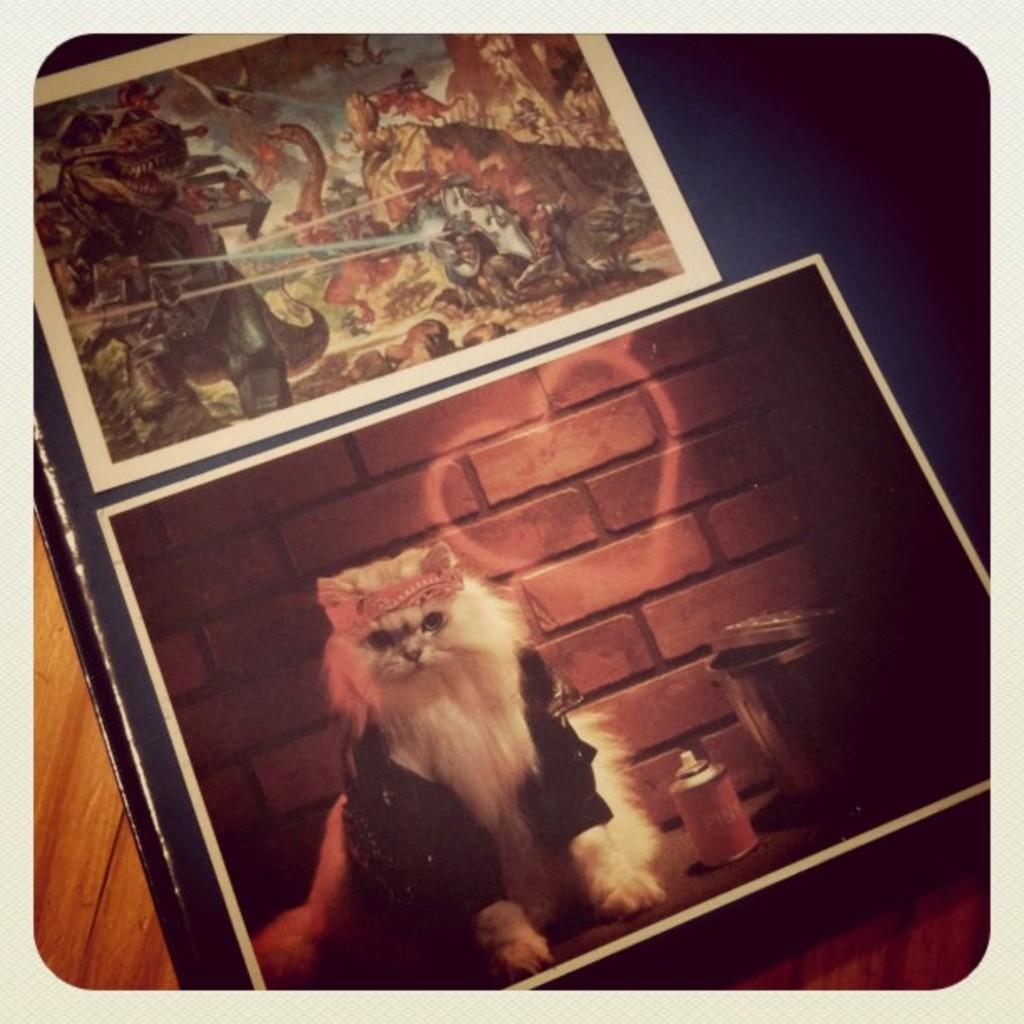What type of object is featured in the frames in the image? The frames contain a picture of a cat. What is the material of the table at the bottom of the image? The table at the bottom of the image is made of wood. What design can be seen on the cat's mind in the image? There is no indication of a cat's mind or any design on it in the image. How many laborers are present in the image? There are no laborers present in the image. 